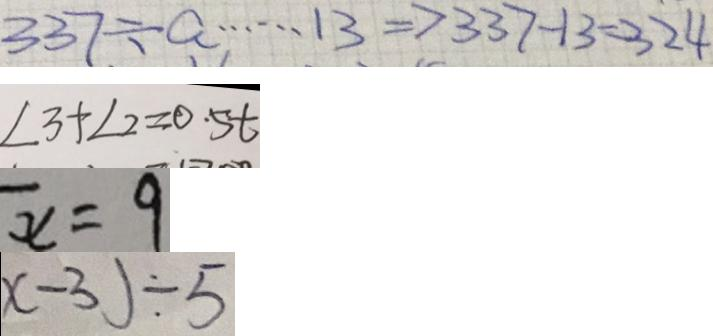Convert formula to latex. <formula><loc_0><loc_0><loc_500><loc_500>3 3 7 \div a \cdots 1 3 \Rightarrow 3 3 7 - 1 3 = 3 2 4 
 \angle 3 + \angle 2 = 0 . 5 t 
 \overline { x } = 9 
 x - 3 ) \div 5</formula> 